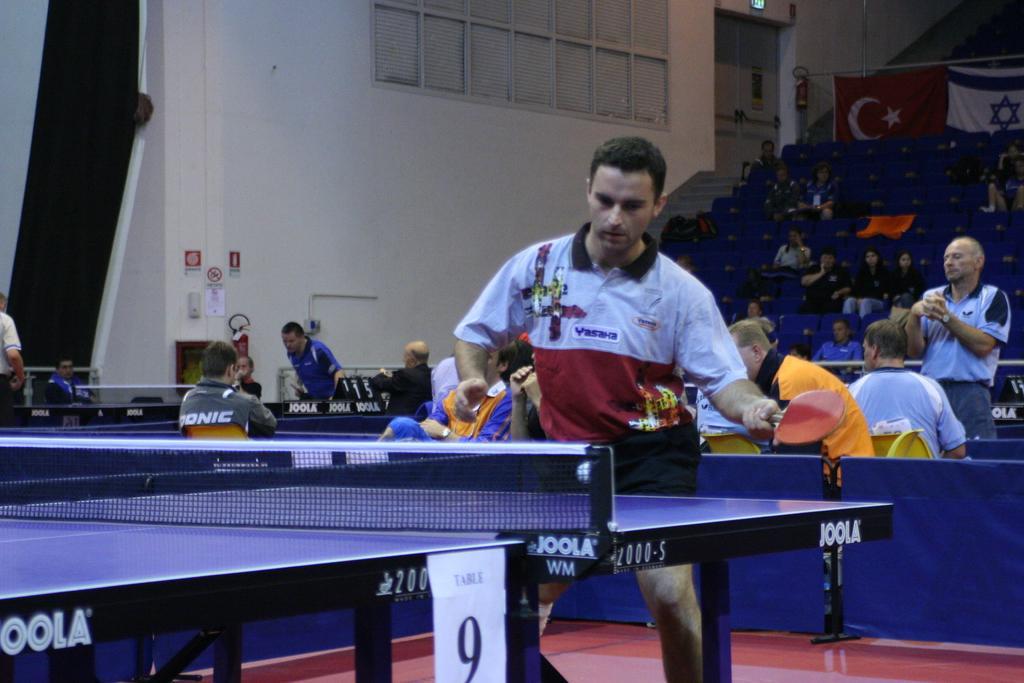Can you describe this image briefly? In the given image we can see person playing table tennis and the audience are encouraging. This is a court, net and a bat. This is a flag of a country. 